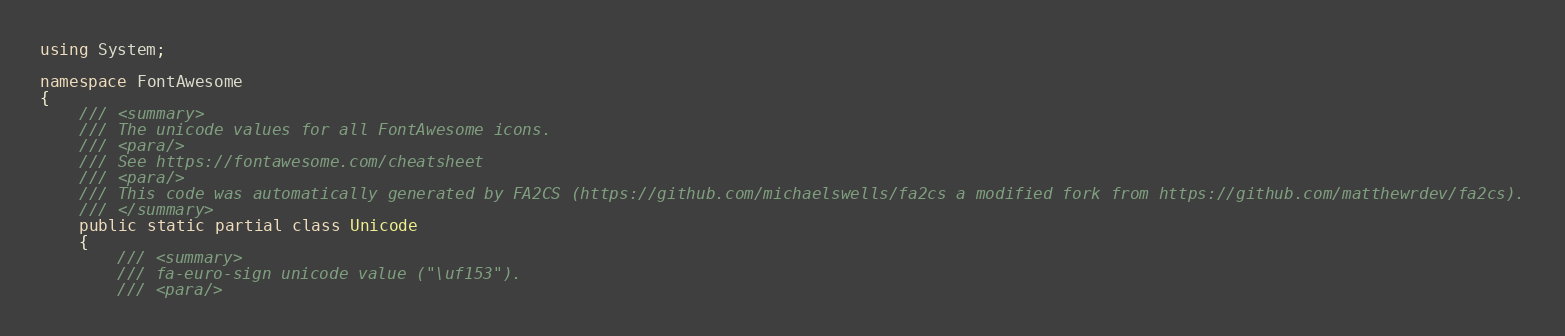<code> <loc_0><loc_0><loc_500><loc_500><_C#_>using System;

namespace FontAwesome
{
    /// <summary>
    /// The unicode values for all FontAwesome icons.
    /// <para/>
    /// See https://fontawesome.com/cheatsheet
    /// <para/>
    /// This code was automatically generated by FA2CS (https://github.com/michaelswells/fa2cs a modified fork from https://github.com/matthewrdev/fa2cs).
    /// </summary>
    public static partial class Unicode
    {
        /// <summary>
        /// fa-euro-sign unicode value ("\uf153").
        /// <para/></code> 